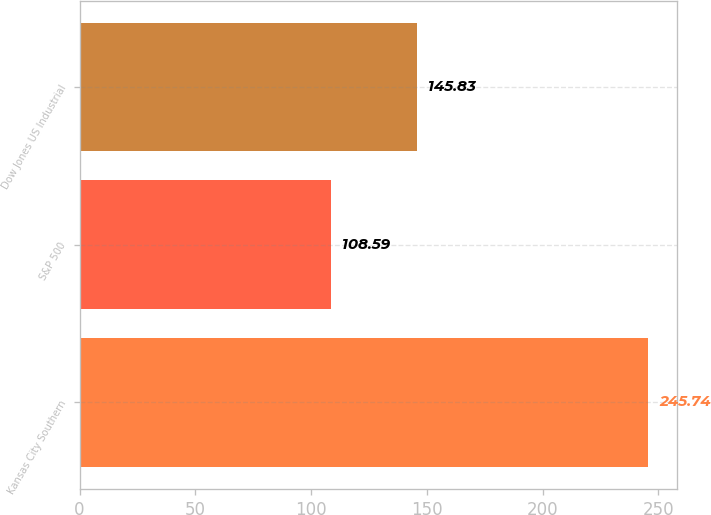Convert chart. <chart><loc_0><loc_0><loc_500><loc_500><bar_chart><fcel>Kansas City Southern<fcel>S&P 500<fcel>Dow Jones US Industrial<nl><fcel>245.74<fcel>108.59<fcel>145.83<nl></chart> 